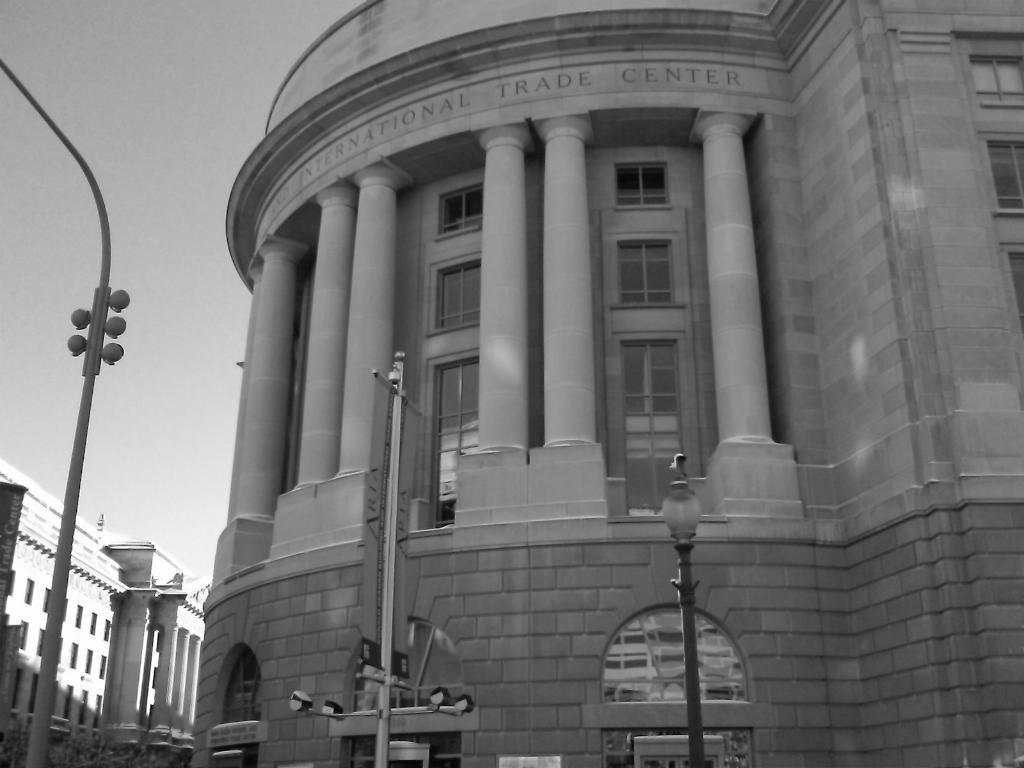Could you give a brief overview of what you see in this image? In this image there are buildings and poles. In the background there is sky. 